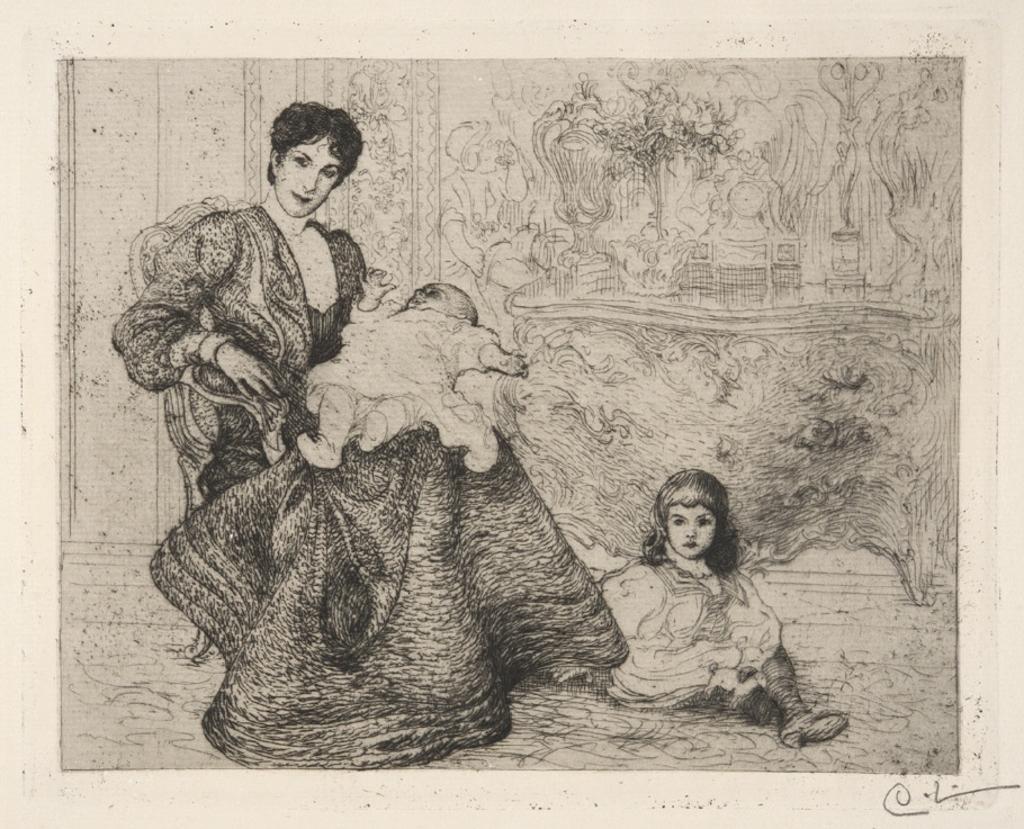In one or two sentences, can you explain what this image depicts? There is a painting. In which, there is a woman sitting on a chair and holding a baby. Beside this chair, there is a girl sitting on the floor. In the background, there is a wall. 